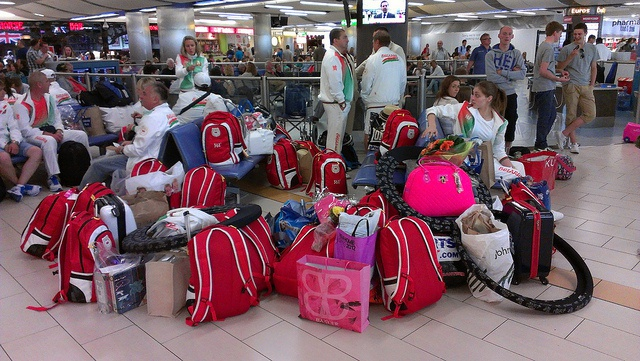Describe the objects in this image and their specific colors. I can see backpack in gray, brown, maroon, and black tones, backpack in gray, brown, maroon, darkgray, and lightgray tones, people in gray, lightgray, darkgray, and black tones, people in gray, darkgray, lavender, and black tones, and people in gray, darkgray, and maroon tones in this image. 